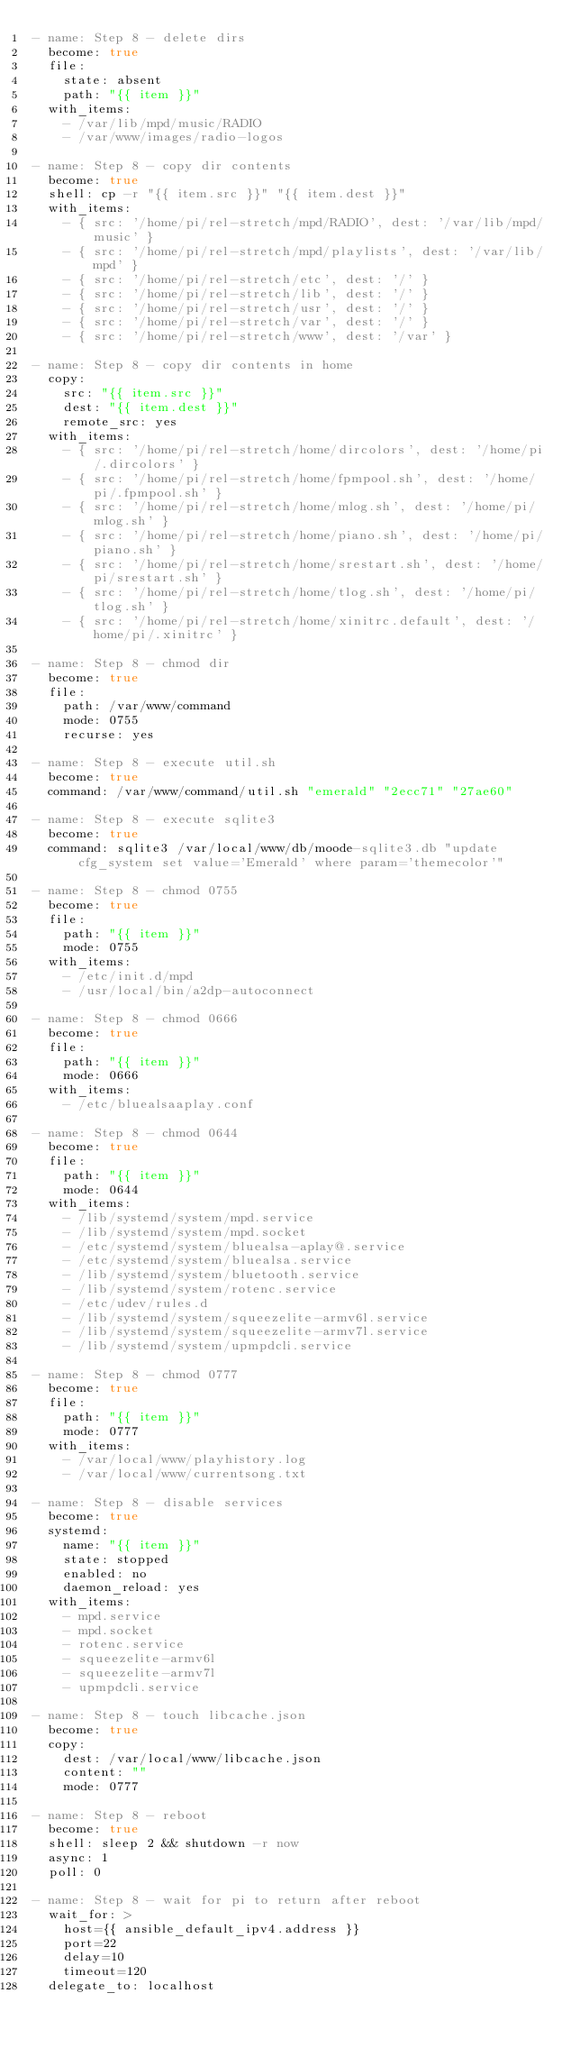Convert code to text. <code><loc_0><loc_0><loc_500><loc_500><_YAML_>- name: Step 8 - delete dirs
  become: true
  file: 
    state: absent
    path: "{{ item }}"
  with_items:
    - /var/lib/mpd/music/RADIO
    - /var/www/images/radio-logos

- name: Step 8 - copy dir contents
  become: true
  shell: cp -r "{{ item.src }}" "{{ item.dest }}"
  with_items:
    - { src: '/home/pi/rel-stretch/mpd/RADIO', dest: '/var/lib/mpd/music' }
    - { src: '/home/pi/rel-stretch/mpd/playlists', dest: '/var/lib/mpd' }
    - { src: '/home/pi/rel-stretch/etc', dest: '/' }
    - { src: '/home/pi/rel-stretch/lib', dest: '/' }
    - { src: '/home/pi/rel-stretch/usr', dest: '/' }
    - { src: '/home/pi/rel-stretch/var', dest: '/' }
    - { src: '/home/pi/rel-stretch/www', dest: '/var' }

- name: Step 8 - copy dir contents in home
  copy:
    src: "{{ item.src }}"
    dest: "{{ item.dest }}"
    remote_src: yes
  with_items:
    - { src: '/home/pi/rel-stretch/home/dircolors', dest: '/home/pi/.dircolors' }
    - { src: '/home/pi/rel-stretch/home/fpmpool.sh', dest: '/home/pi/.fpmpool.sh' }
    - { src: '/home/pi/rel-stretch/home/mlog.sh', dest: '/home/pi/mlog.sh' }
    - { src: '/home/pi/rel-stretch/home/piano.sh', dest: '/home/pi/piano.sh' }
    - { src: '/home/pi/rel-stretch/home/srestart.sh', dest: '/home/pi/srestart.sh' }
    - { src: '/home/pi/rel-stretch/home/tlog.sh', dest: '/home/pi/tlog.sh' }
    - { src: '/home/pi/rel-stretch/home/xinitrc.default', dest: '/home/pi/.xinitrc' }

- name: Step 8 - chmod dir
  become: true
  file: 
    path: /var/www/command
    mode: 0755
    recurse: yes

- name: Step 8 - execute util.sh
  become: true
  command: /var/www/command/util.sh "emerald" "2ecc71" "27ae60"

- name: Step 8 - execute sqlite3
  become: true
  command: sqlite3 /var/local/www/db/moode-sqlite3.db "update cfg_system set value='Emerald' where param='themecolor'"

- name: Step 8 - chmod 0755
  become: true
  file: 
    path: "{{ item }}"
    mode: 0755
  with_items:
    - /etc/init.d/mpd
    - /usr/local/bin/a2dp-autoconnect

- name: Step 8 - chmod 0666
  become: true
  file: 
    path: "{{ item }}"
    mode: 0666
  with_items:
    - /etc/bluealsaaplay.conf

- name: Step 8 - chmod 0644
  become: true
  file: 
    path: "{{ item }}"
    mode: 0644
  with_items:
    - /lib/systemd/system/mpd.service
    - /lib/systemd/system/mpd.socket
    - /etc/systemd/system/bluealsa-aplay@.service
    - /etc/systemd/system/bluealsa.service
    - /lib/systemd/system/bluetooth.service
    - /lib/systemd/system/rotenc.service
    - /etc/udev/rules.d
    - /lib/systemd/system/squeezelite-armv6l.service
    - /lib/systemd/system/squeezelite-armv7l.service
    - /lib/systemd/system/upmpdcli.service

- name: Step 8 - chmod 0777
  become: true
  file: 
    path: "{{ item }}"
    mode: 0777
  with_items:
    - /var/local/www/playhistory.log
    - /var/local/www/currentsong.txt

- name: Step 8 - disable services
  become: true
  systemd:
    name: "{{ item }}"
    state: stopped
    enabled: no
    daemon_reload: yes
  with_items:
    - mpd.service
    - mpd.socket
    - rotenc.service
    - squeezelite-armv6l
    - squeezelite-armv7l
    - upmpdcli.service

- name: Step 8 - touch libcache.json
  become: true
  copy: 
    dest: /var/local/www/libcache.json
    content: ""
    mode: 0777

- name: Step 8 - reboot
  become: true
  shell: sleep 2 && shutdown -r now
  async: 1
  poll: 0

- name: Step 8 - wait for pi to return after reboot
  wait_for: >
    host={{ ansible_default_ipv4.address }}
    port=22
    delay=10
    timeout=120
  delegate_to: localhost</code> 